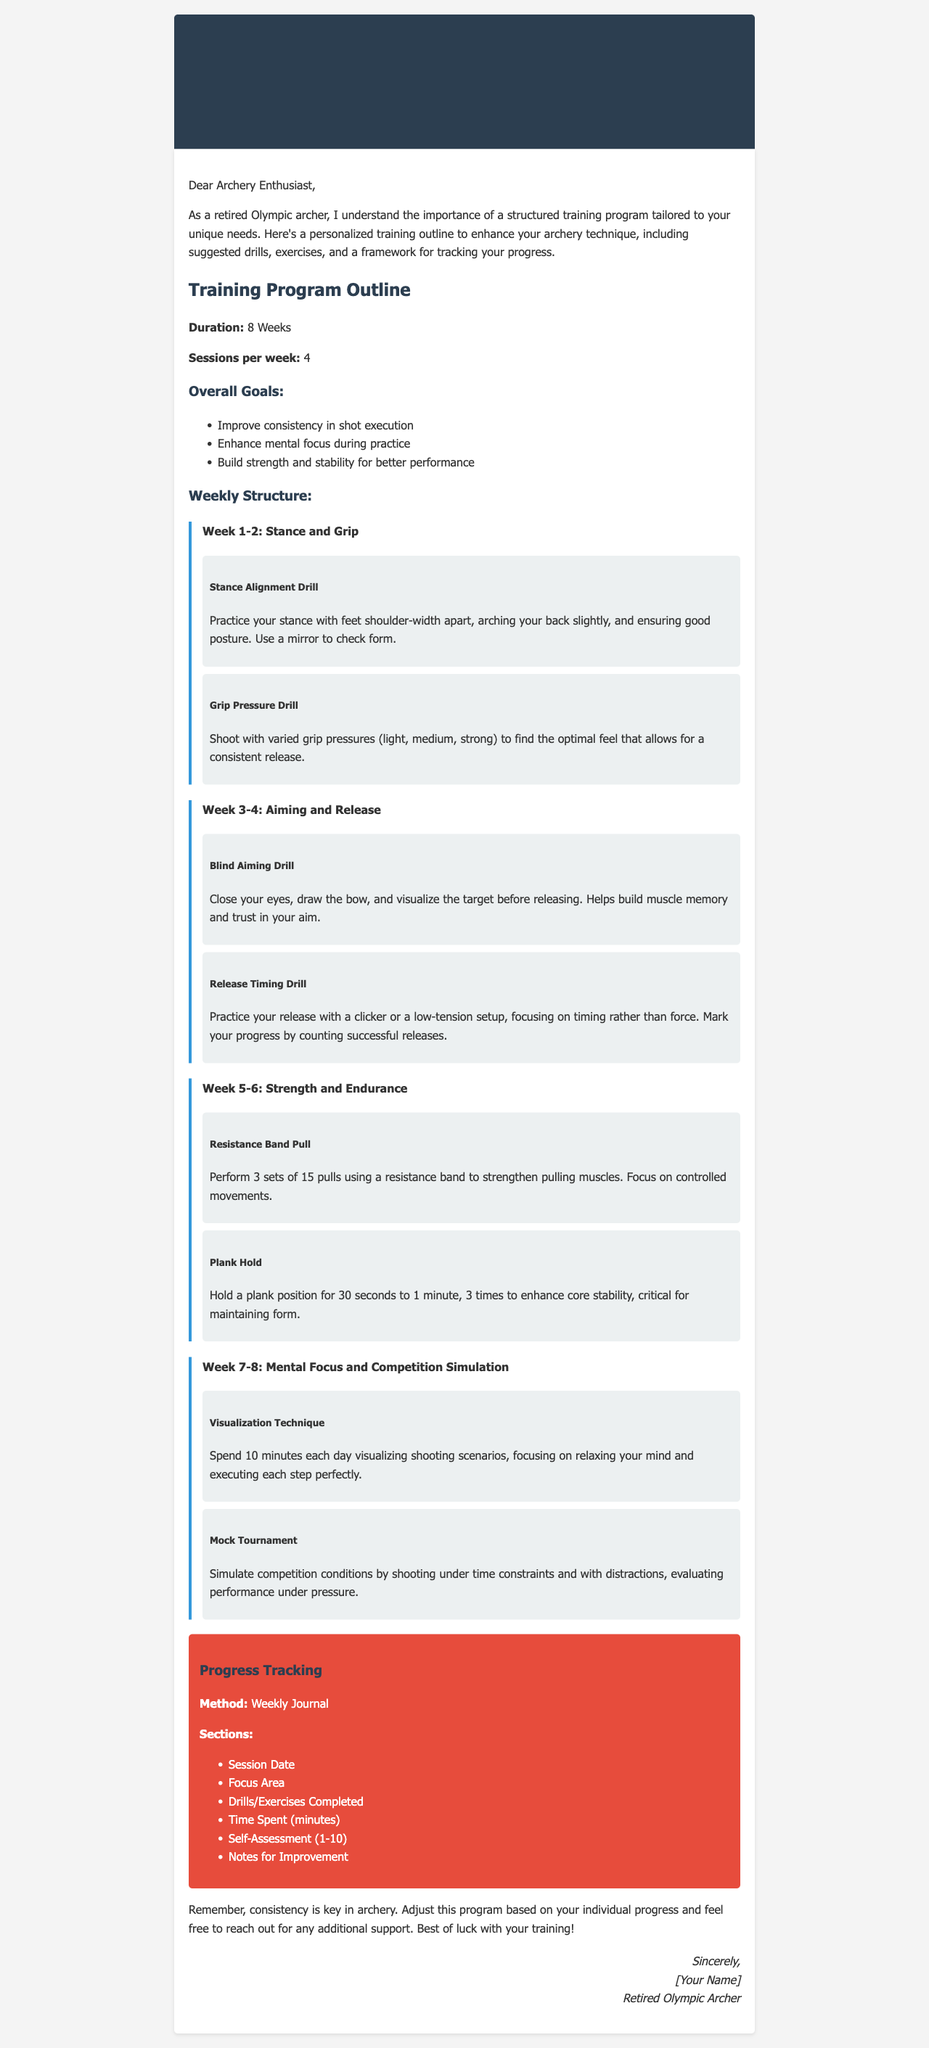what is the duration of the training program? The document specifies that the duration of the training program is 8 weeks.
Answer: 8 weeks how many sessions are suggested per week? The program outline mentions that there should be 4 sessions per week.
Answer: 4 what is one overall goal of the training program? The document lists several overall goals, such as improving consistency in shot execution.
Answer: Improve consistency in shot execution what drill is suggested for stance alignment? The document names "Stance Alignment Drill" as a drill for improving stance.
Answer: Stance Alignment Drill how often should the plank hold exercise be performed? The exercise section states that it should be performed three times.
Answer: 3 times what method is recommended for progress tracking? The document suggests using a "Weekly Journal" to track progress.
Answer: Weekly Journal what is the focus area during weeks 5-6? The focus area during weeks 5-6 is "Strength and Endurance".
Answer: Strength and Endurance what visualization technique is mentioned for mental focus? The document refers to "Visualization Technique" to enhance mental focus.
Answer: Visualization Technique how long is the plank hold suggested to last? The document suggests holding the plank position for 30 seconds to 1 minute.
Answer: 30 seconds to 1 minute 